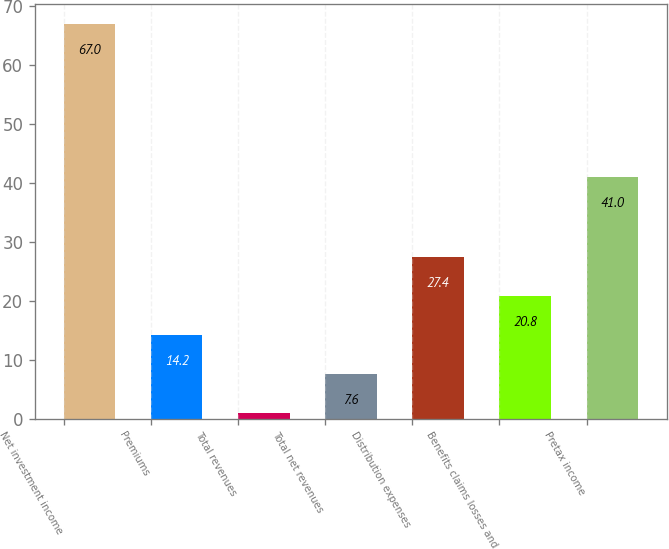Convert chart. <chart><loc_0><loc_0><loc_500><loc_500><bar_chart><fcel>Net investment income<fcel>Premiums<fcel>Total revenues<fcel>Total net revenues<fcel>Distribution expenses<fcel>Benefits claims losses and<fcel>Pretax income<nl><fcel>67<fcel>14.2<fcel>1<fcel>7.6<fcel>27.4<fcel>20.8<fcel>41<nl></chart> 